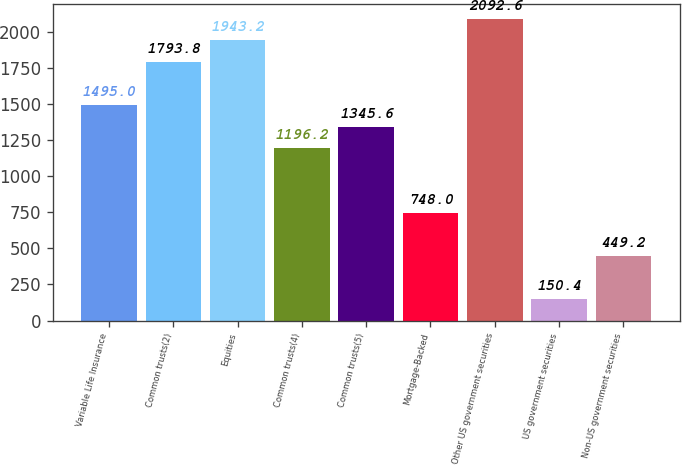<chart> <loc_0><loc_0><loc_500><loc_500><bar_chart><fcel>Variable Life Insurance<fcel>Common trusts(2)<fcel>Equities<fcel>Common trusts(4)<fcel>Common trusts(5)<fcel>Mortgage-Backed<fcel>Other US government securities<fcel>US government securities<fcel>Non-US government securities<nl><fcel>1495<fcel>1793.8<fcel>1943.2<fcel>1196.2<fcel>1345.6<fcel>748<fcel>2092.6<fcel>150.4<fcel>449.2<nl></chart> 